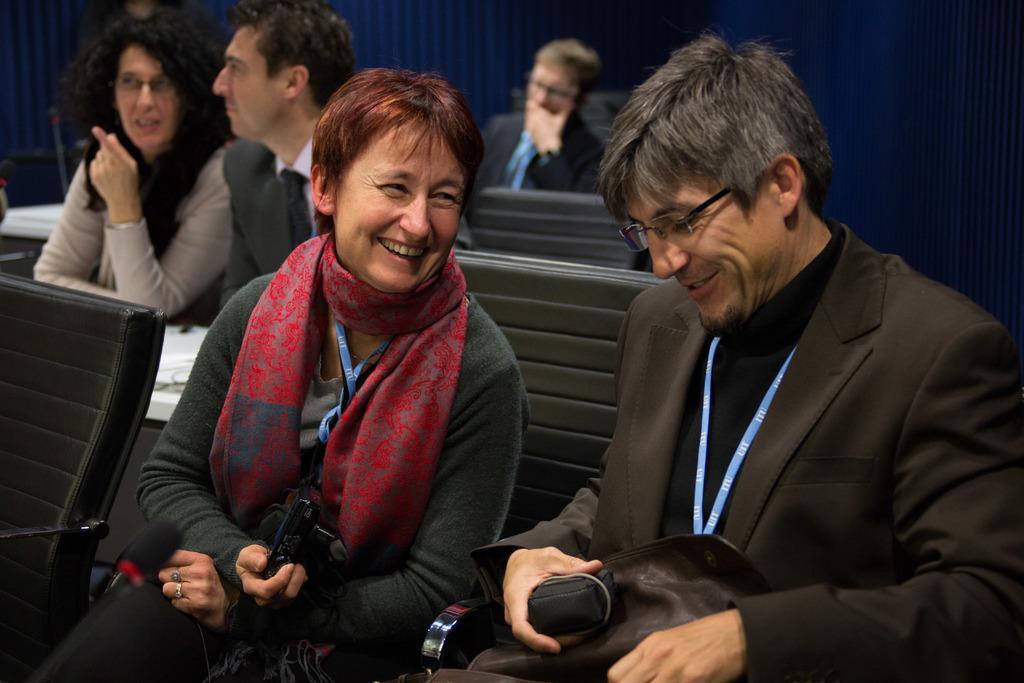In one or two sentences, can you explain what this image depicts? In this image there are two persons sitting on the chairs and smiling , a person holding a camera , and in the background there are 3 persons sitting on the chairs. 